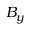<formula> <loc_0><loc_0><loc_500><loc_500>B _ { y }</formula> 